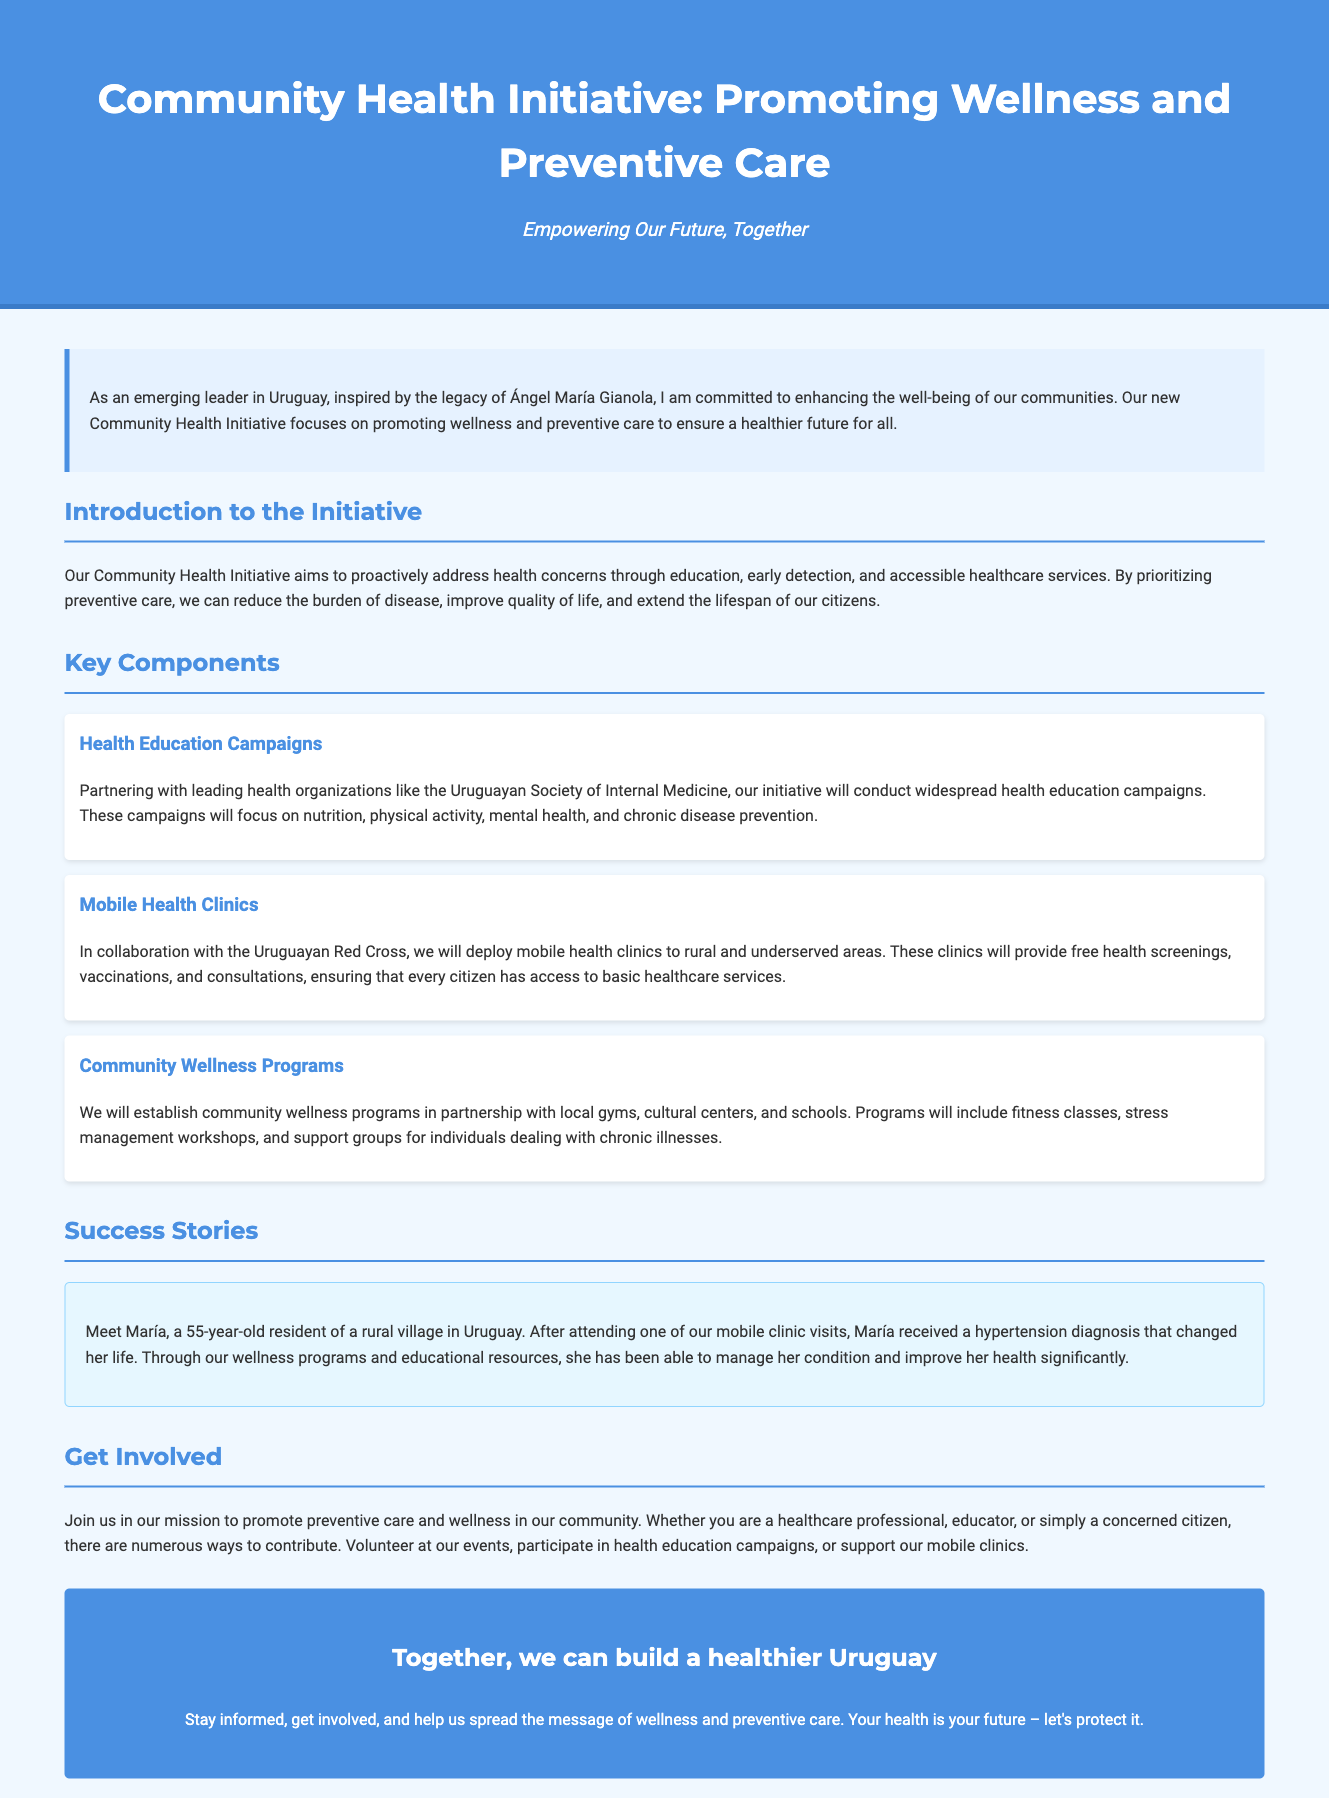what is the title of the initiative? The title of the initiative is explicitly stated at the top of the document.
Answer: Community Health Initiative: Promoting Wellness and Preventive Care who is partnering with for health education campaigns? The document mentions the Uruguayan Society of Internal Medicine as a partner.
Answer: Uruguayan Society of Internal Medicine what type of clinics will be deployed to rural areas? The document specifies the type of clinics that will be used to provide healthcare services.
Answer: Mobile health clinics what success story is highlighted in the document? The document features a specific individual who benefited from the initiative.
Answer: María what can citizens do to support the initiative? The document describes ways for the community to get involved with the initiative's goals.
Answer: Volunteer at our events how will the initiative improve access to healthcare? The document explains the method used to provide healthcare services to underserved areas.
Answer: Mobile health clinics 